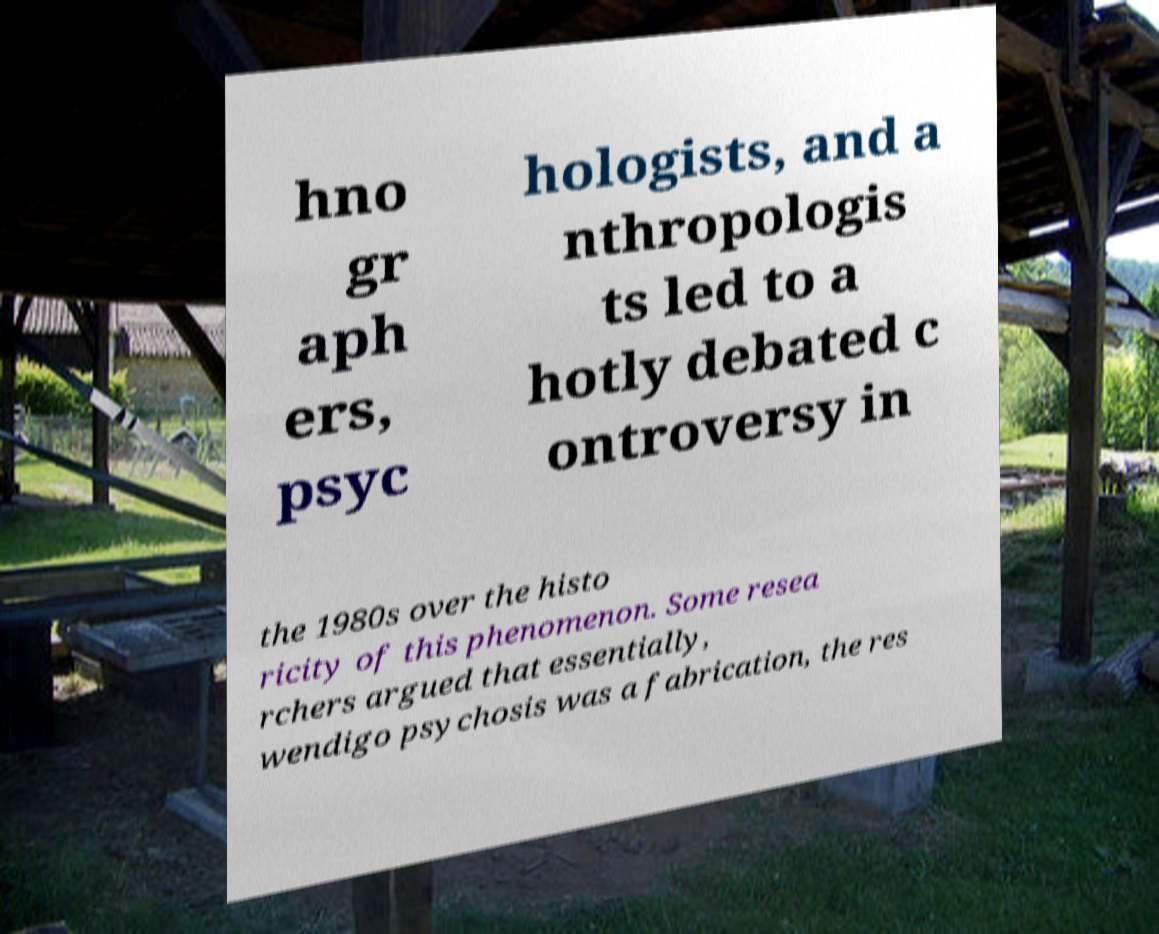Can you read and provide the text displayed in the image?This photo seems to have some interesting text. Can you extract and type it out for me? hno gr aph ers, psyc hologists, and a nthropologis ts led to a hotly debated c ontroversy in the 1980s over the histo ricity of this phenomenon. Some resea rchers argued that essentially, wendigo psychosis was a fabrication, the res 